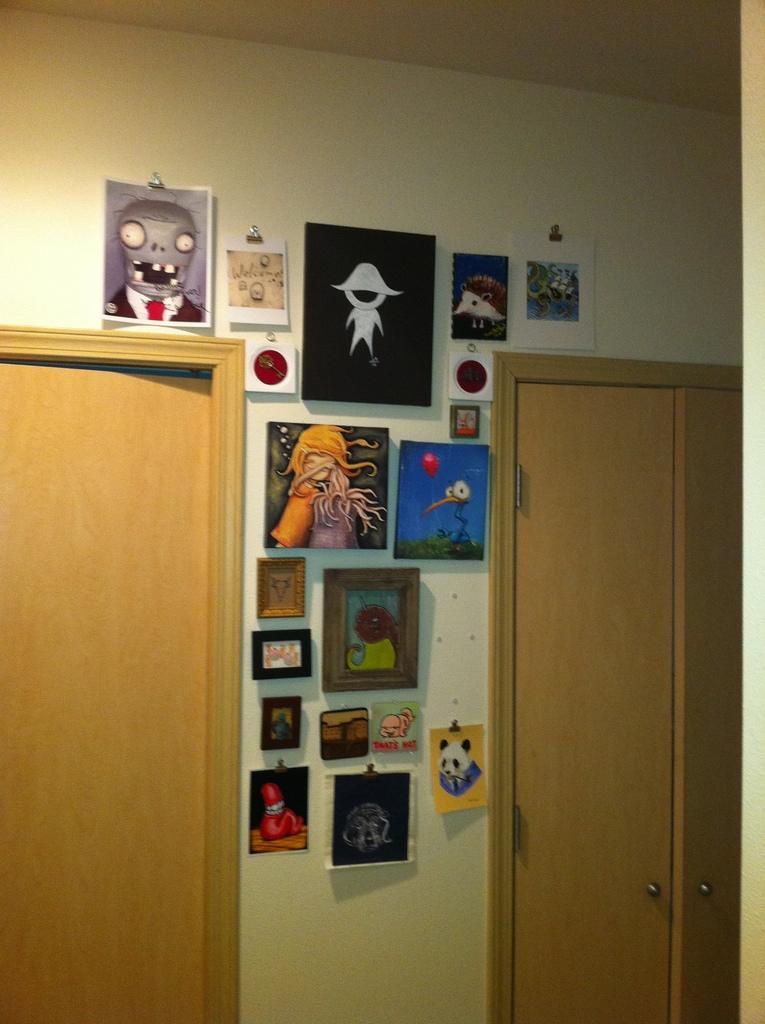Could you give a brief overview of what you see in this image? This is an inside view of a room. On the right and left sides of the image I can see the doors. Between the doors few frames and posters are attached to the wall. 